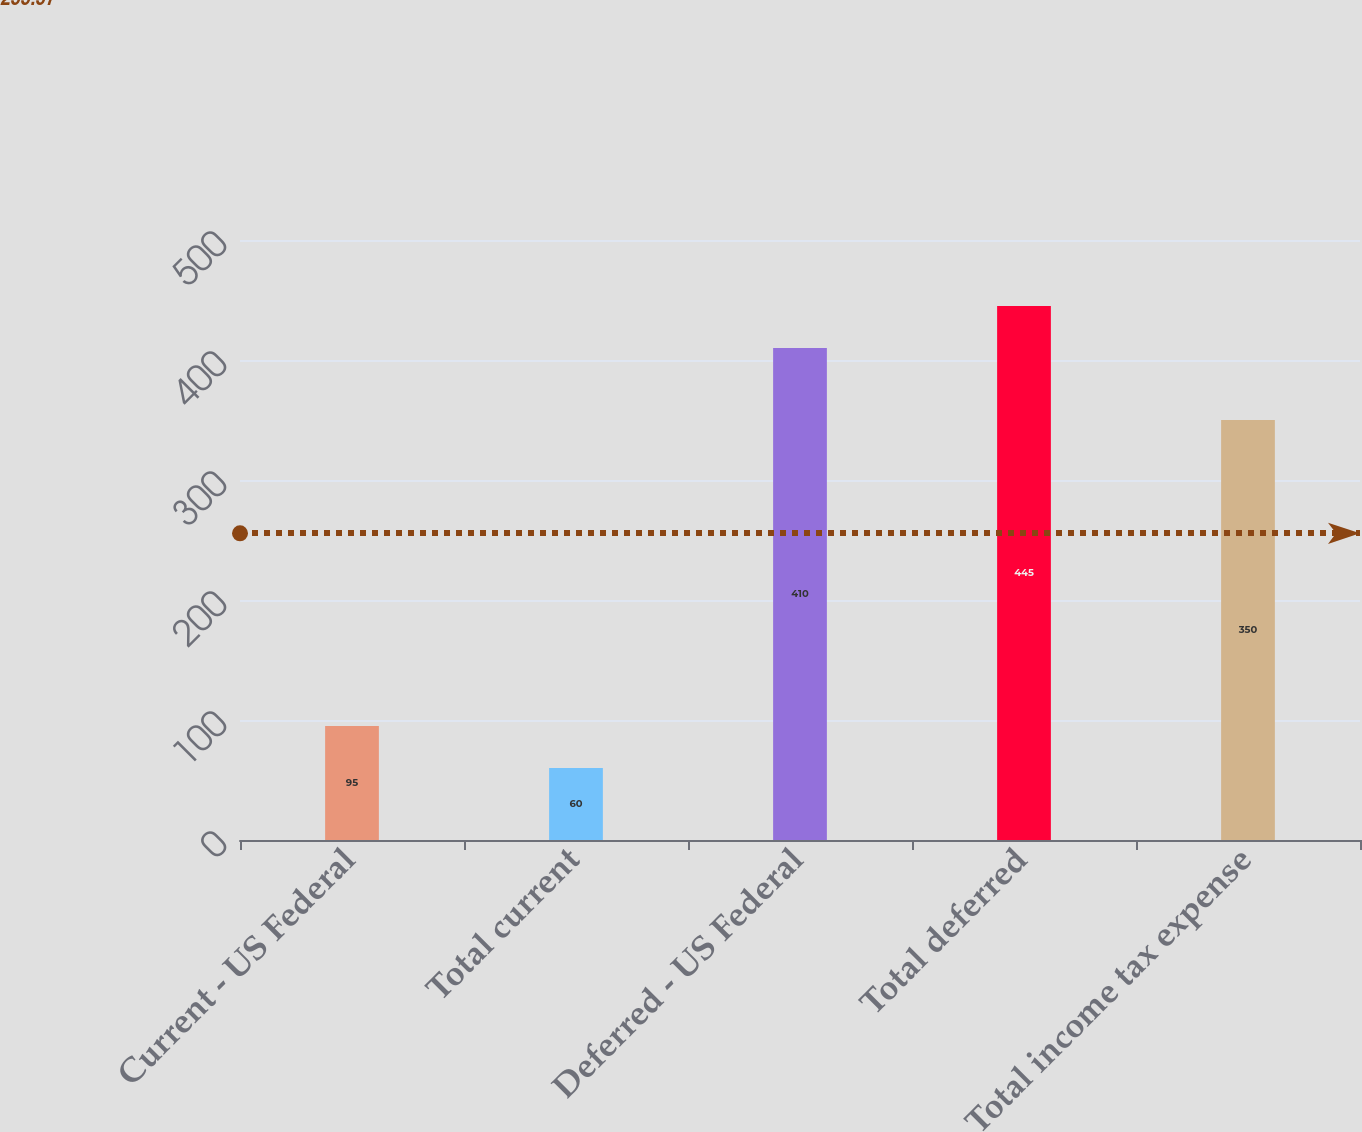Convert chart to OTSL. <chart><loc_0><loc_0><loc_500><loc_500><bar_chart><fcel>Current - US Federal<fcel>Total current<fcel>Deferred - US Federal<fcel>Total deferred<fcel>Total income tax expense<nl><fcel>95<fcel>60<fcel>410<fcel>445<fcel>350<nl></chart> 